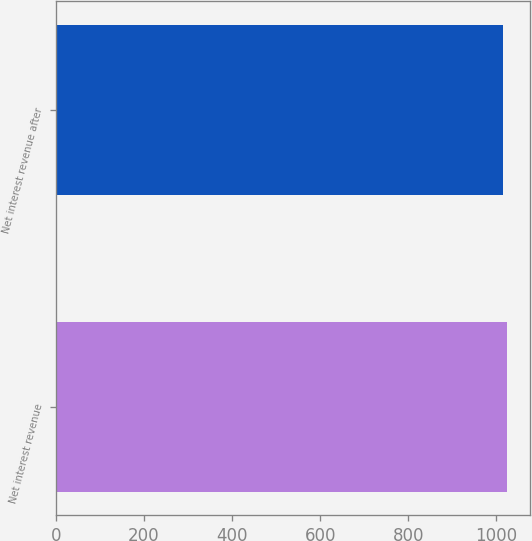Convert chart to OTSL. <chart><loc_0><loc_0><loc_500><loc_500><bar_chart><fcel>Net interest revenue<fcel>Net interest revenue after<nl><fcel>1025<fcel>1015<nl></chart> 